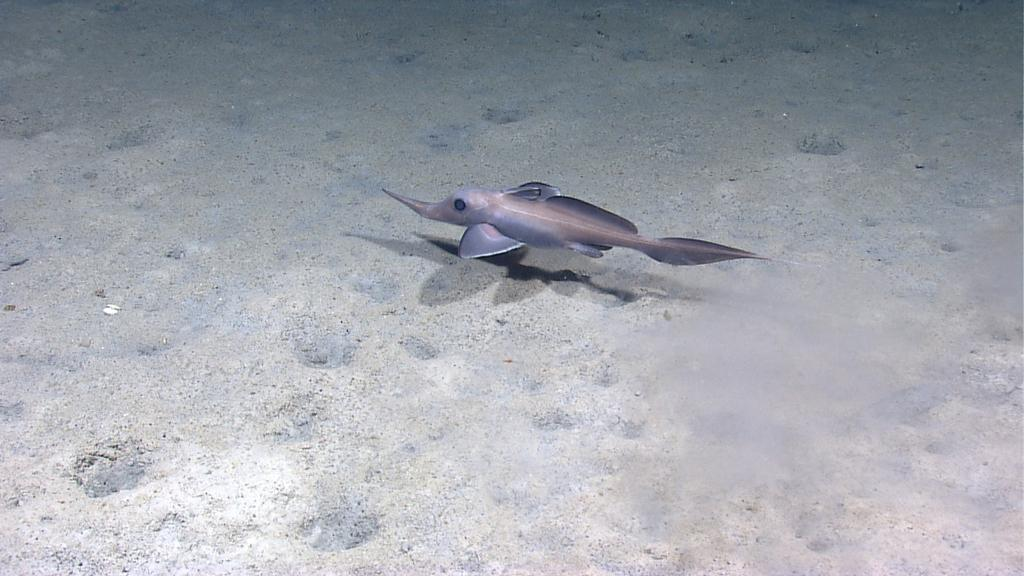What type of animal is in the image? There is a fish in the image. Where is the fish located? The fish is in the water. What can be seen at the bottom of the image? There is mud visible at the bottom of the image. What type of border is visible around the fish in the image? There is no border visible around the fish in the image; it is swimming freely in the water. 